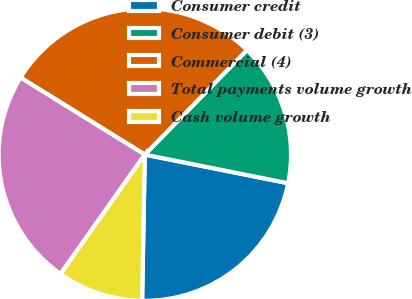Convert chart to OTSL. <chart><loc_0><loc_0><loc_500><loc_500><pie_chart><fcel>Consumer credit<fcel>Consumer debit (3)<fcel>Commercial (4)<fcel>Total payments volume growth<fcel>Cash volume growth<nl><fcel>22.15%<fcel>15.82%<fcel>28.48%<fcel>24.05%<fcel>9.49%<nl></chart> 